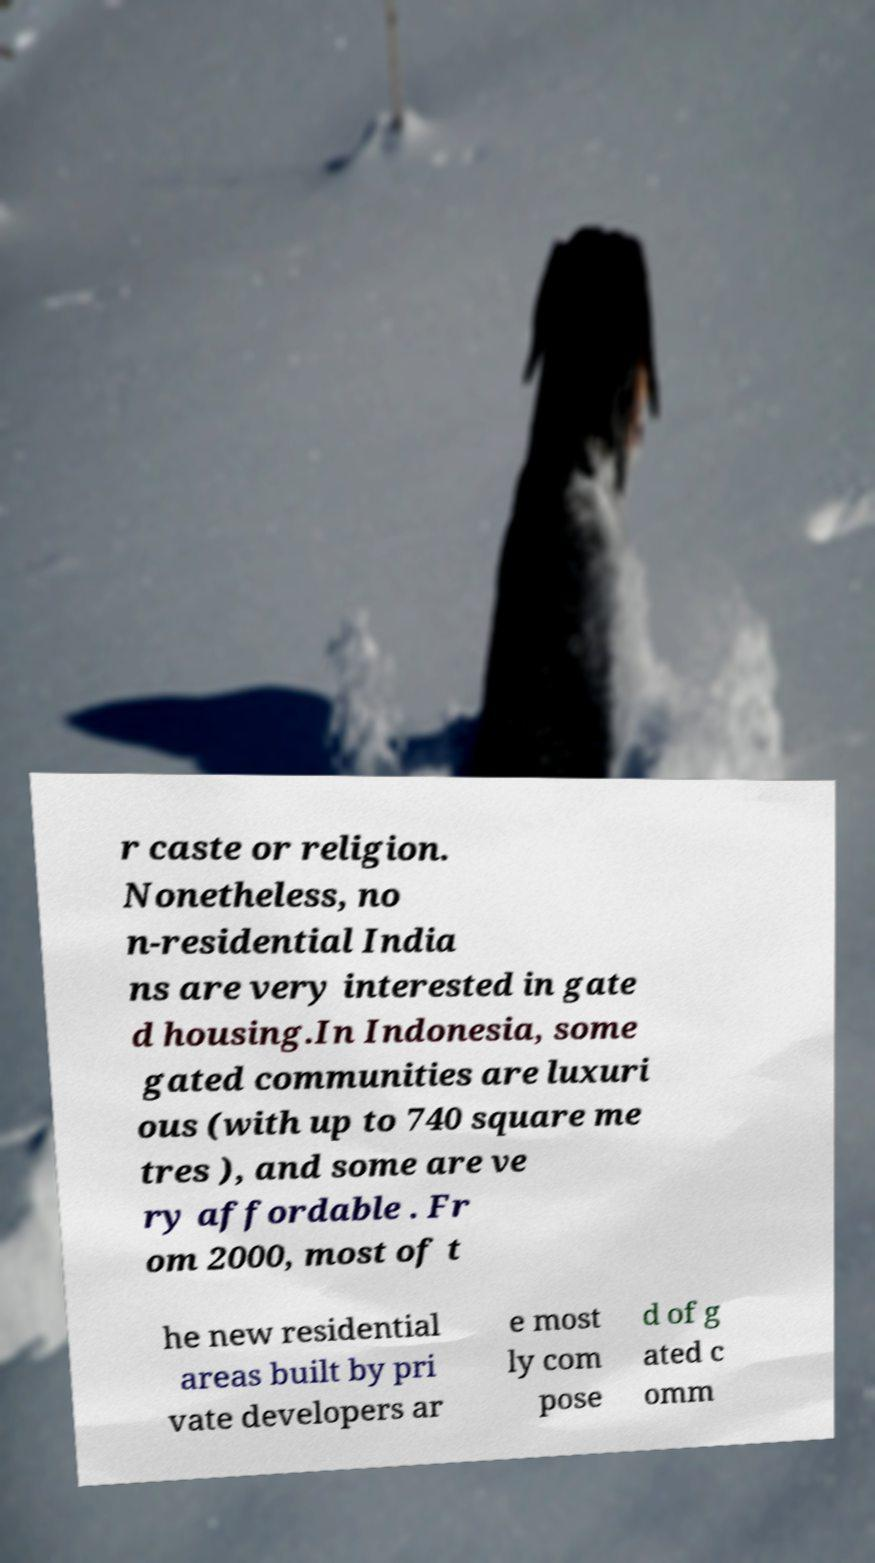I need the written content from this picture converted into text. Can you do that? r caste or religion. Nonetheless, no n-residential India ns are very interested in gate d housing.In Indonesia, some gated communities are luxuri ous (with up to 740 square me tres ), and some are ve ry affordable . Fr om 2000, most of t he new residential areas built by pri vate developers ar e most ly com pose d of g ated c omm 